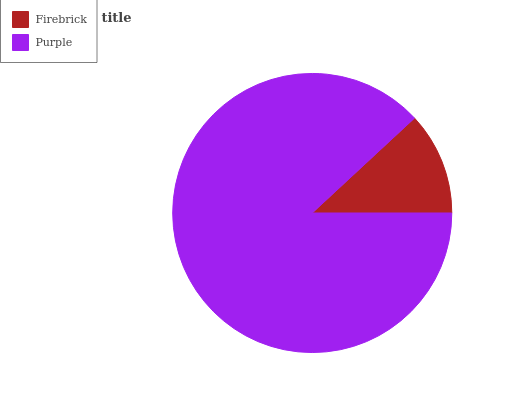Is Firebrick the minimum?
Answer yes or no. Yes. Is Purple the maximum?
Answer yes or no. Yes. Is Purple the minimum?
Answer yes or no. No. Is Purple greater than Firebrick?
Answer yes or no. Yes. Is Firebrick less than Purple?
Answer yes or no. Yes. Is Firebrick greater than Purple?
Answer yes or no. No. Is Purple less than Firebrick?
Answer yes or no. No. Is Purple the high median?
Answer yes or no. Yes. Is Firebrick the low median?
Answer yes or no. Yes. Is Firebrick the high median?
Answer yes or no. No. Is Purple the low median?
Answer yes or no. No. 